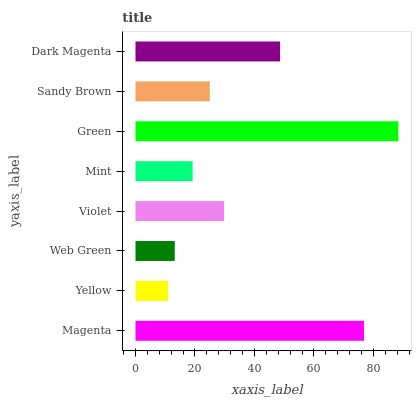Is Yellow the minimum?
Answer yes or no. Yes. Is Green the maximum?
Answer yes or no. Yes. Is Web Green the minimum?
Answer yes or no. No. Is Web Green the maximum?
Answer yes or no. No. Is Web Green greater than Yellow?
Answer yes or no. Yes. Is Yellow less than Web Green?
Answer yes or no. Yes. Is Yellow greater than Web Green?
Answer yes or no. No. Is Web Green less than Yellow?
Answer yes or no. No. Is Violet the high median?
Answer yes or no. Yes. Is Sandy Brown the low median?
Answer yes or no. Yes. Is Mint the high median?
Answer yes or no. No. Is Green the low median?
Answer yes or no. No. 